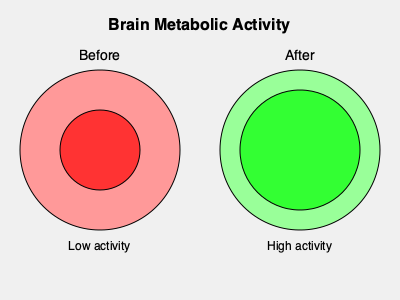Based on the brain scans shown, which area of the brain appears to have experienced the most significant increase in metabolic activity following dietary changes, and what nutritional intervention might have contributed to this change? 1. Observe the "Before" and "After" brain scans:
   - The "Before" scan shows a smaller area of high metabolic activity (dark red center).
   - The "After" scan shows a larger area of high metabolic activity (dark green center).

2. Identify the change:
   - The central region of the brain shows the most significant increase in metabolic activity.
   - This area likely corresponds to the prefrontal cortex, which is involved in executive functions, decision-making, and mood regulation.

3. Consider potential nutritional interventions:
   - Omega-3 fatty acids, particularly EPA and DHA, are known to support brain health and function.
   - These essential fatty acids are found in fatty fish, fish oil supplements, and algae-based supplements.

4. Connect the intervention to the observed change:
   - Omega-3 fatty acids have been shown to improve brain metabolism and reduce inflammation.
   - They can enhance neurotransmitter function and promote neuroplasticity.

5. Conclude the likely nutritional intervention:
   - Given the significant increase in prefrontal cortex activity, a diet rich in omega-3 fatty acids or omega-3 supplementation is a plausible nutritional intervention that could have contributed to this change.
Answer: Prefrontal cortex; omega-3 fatty acid supplementation 